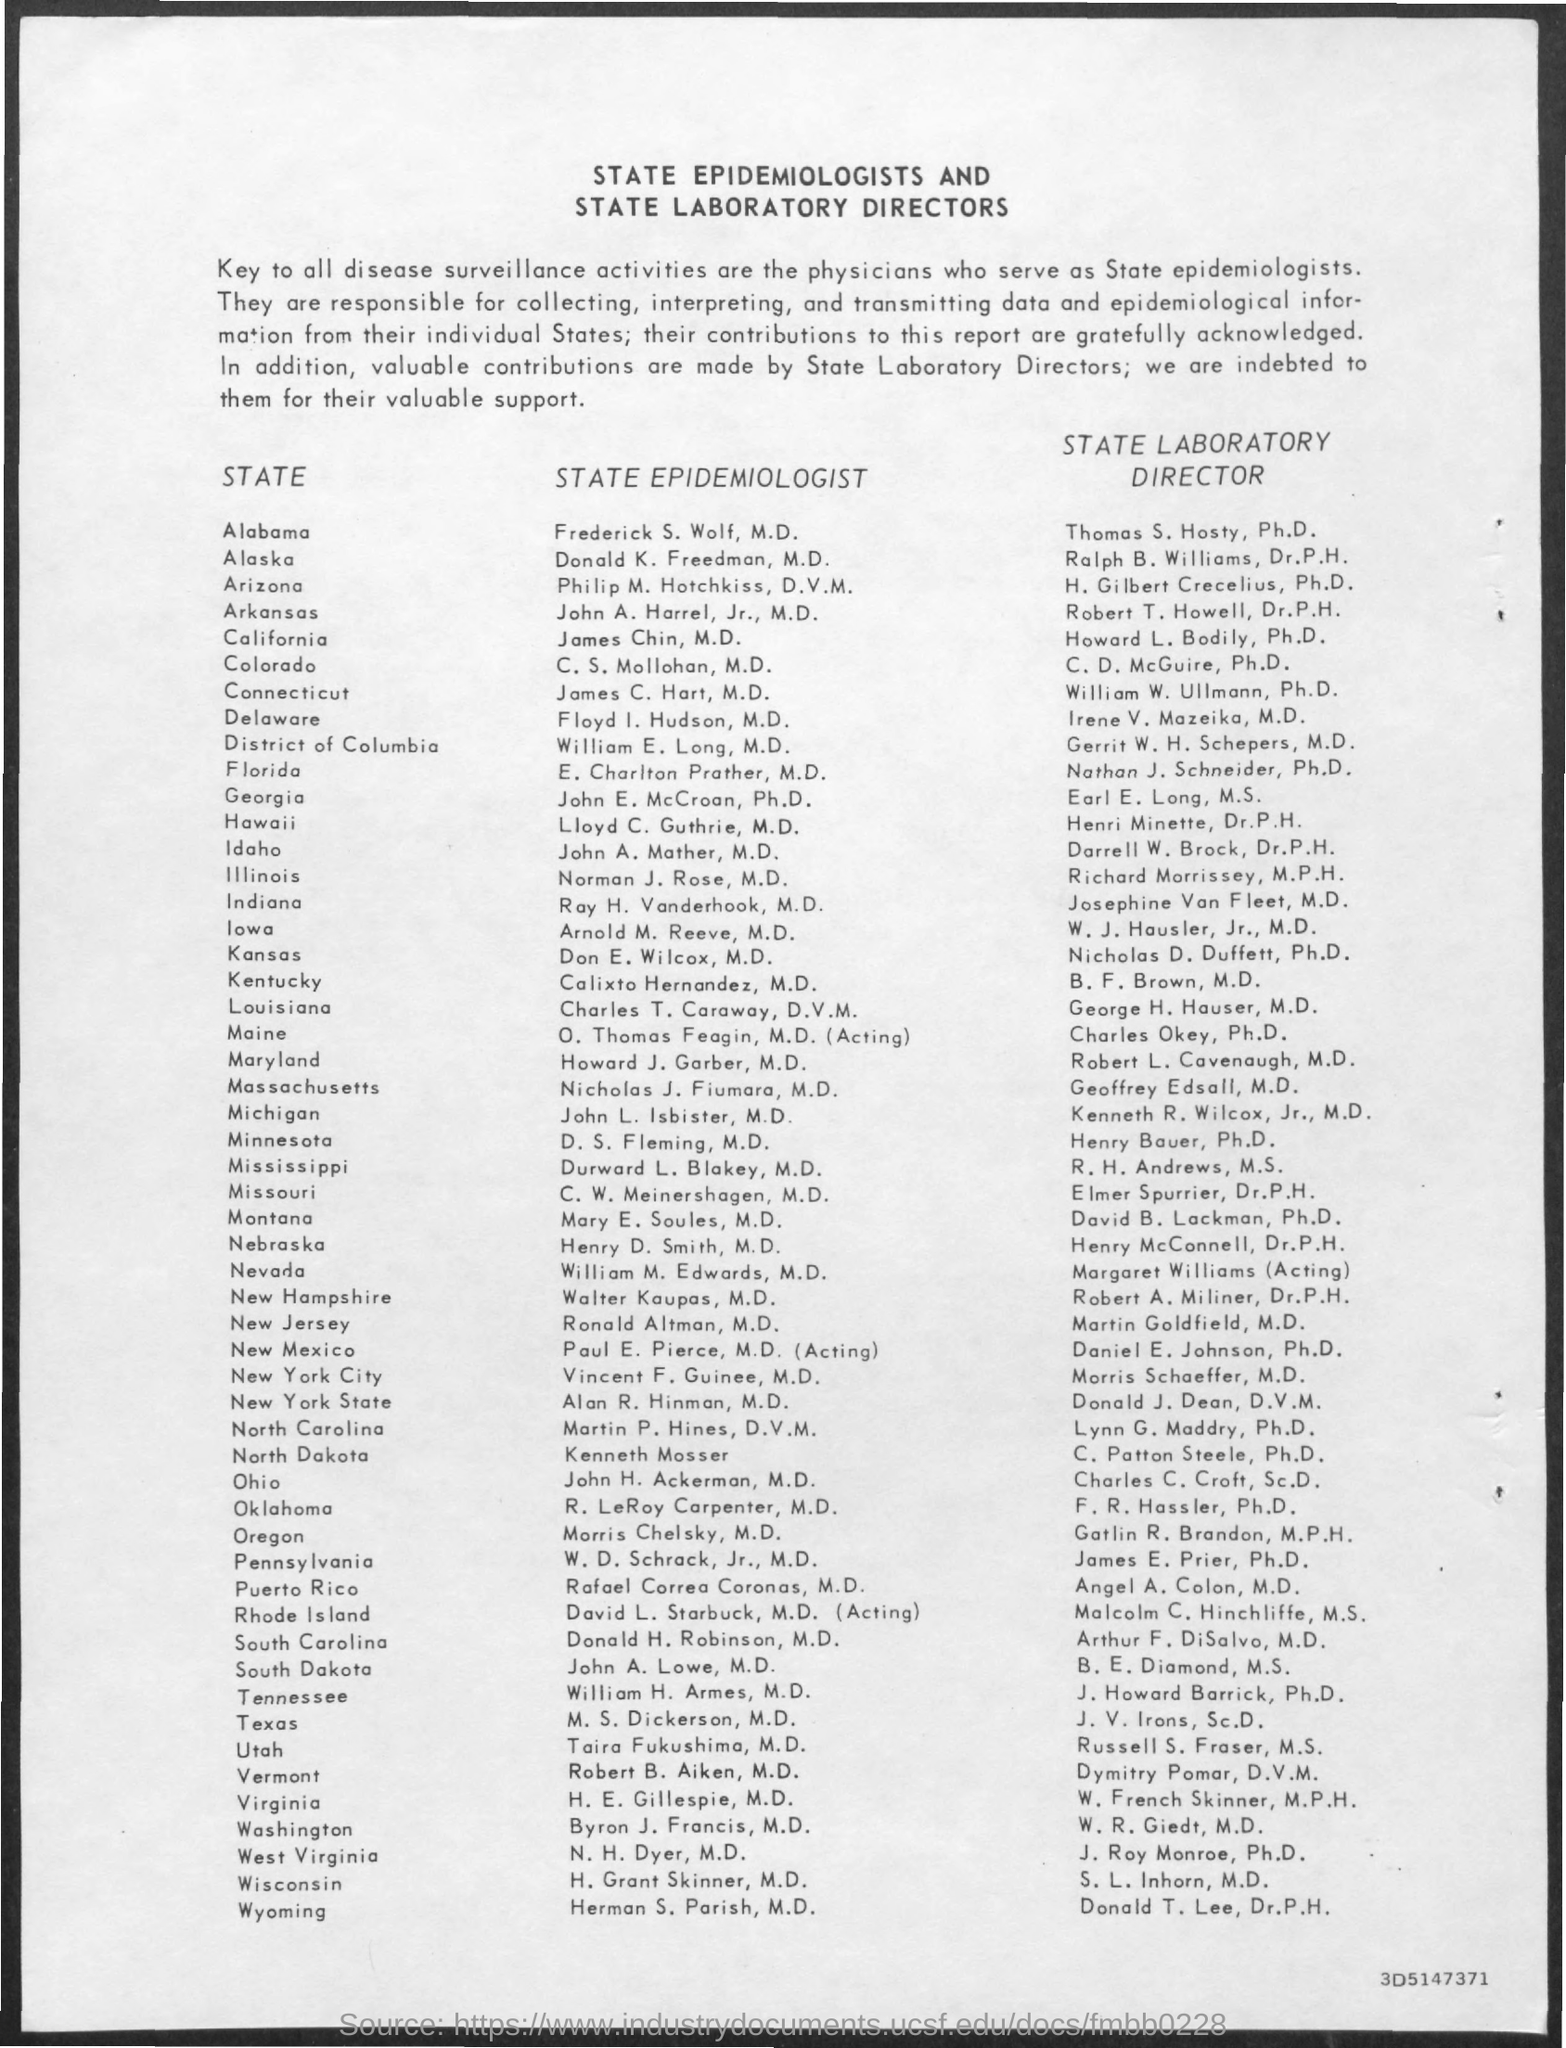What is the heading?
Provide a succinct answer. State epidemiologists and state laboratory directors. Who are the key to all disease surveillance activities?
Provide a succinct answer. Physicians who serve as state epidemiologists. Who is the state epidemiologist of alabama?
Keep it short and to the point. Frederick s. wolf. Who is the state laboratory director of alabama?
Make the answer very short. Thomas S. Hosty. 